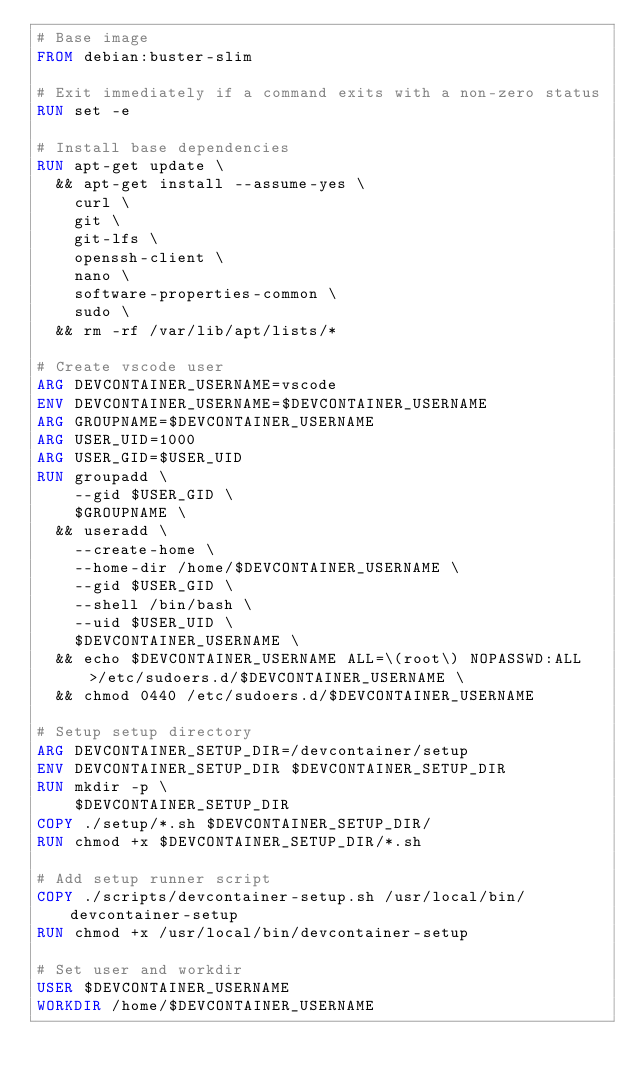Convert code to text. <code><loc_0><loc_0><loc_500><loc_500><_Dockerfile_># Base image
FROM debian:buster-slim

# Exit immediately if a command exits with a non-zero status
RUN set -e

# Install base dependencies
RUN apt-get update \
  && apt-get install --assume-yes \
    curl \
    git \
    git-lfs \
    openssh-client \
    nano \
    software-properties-common \
    sudo \
  && rm -rf /var/lib/apt/lists/*

# Create vscode user
ARG DEVCONTAINER_USERNAME=vscode
ENV DEVCONTAINER_USERNAME=$DEVCONTAINER_USERNAME
ARG GROUPNAME=$DEVCONTAINER_USERNAME
ARG USER_UID=1000
ARG USER_GID=$USER_UID
RUN groupadd \
    --gid $USER_GID \
    $GROUPNAME \
  && useradd \
    --create-home \
    --home-dir /home/$DEVCONTAINER_USERNAME \
    --gid $USER_GID \
    --shell /bin/bash \
    --uid $USER_UID \
    $DEVCONTAINER_USERNAME \
  && echo $DEVCONTAINER_USERNAME ALL=\(root\) NOPASSWD:ALL >/etc/sudoers.d/$DEVCONTAINER_USERNAME \
  && chmod 0440 /etc/sudoers.d/$DEVCONTAINER_USERNAME

# Setup setup directory
ARG DEVCONTAINER_SETUP_DIR=/devcontainer/setup
ENV DEVCONTAINER_SETUP_DIR $DEVCONTAINER_SETUP_DIR
RUN mkdir -p \
    $DEVCONTAINER_SETUP_DIR
COPY ./setup/*.sh $DEVCONTAINER_SETUP_DIR/
RUN chmod +x $DEVCONTAINER_SETUP_DIR/*.sh

# Add setup runner script
COPY ./scripts/devcontainer-setup.sh /usr/local/bin/devcontainer-setup
RUN chmod +x /usr/local/bin/devcontainer-setup

# Set user and workdir
USER $DEVCONTAINER_USERNAME
WORKDIR /home/$DEVCONTAINER_USERNAME
</code> 